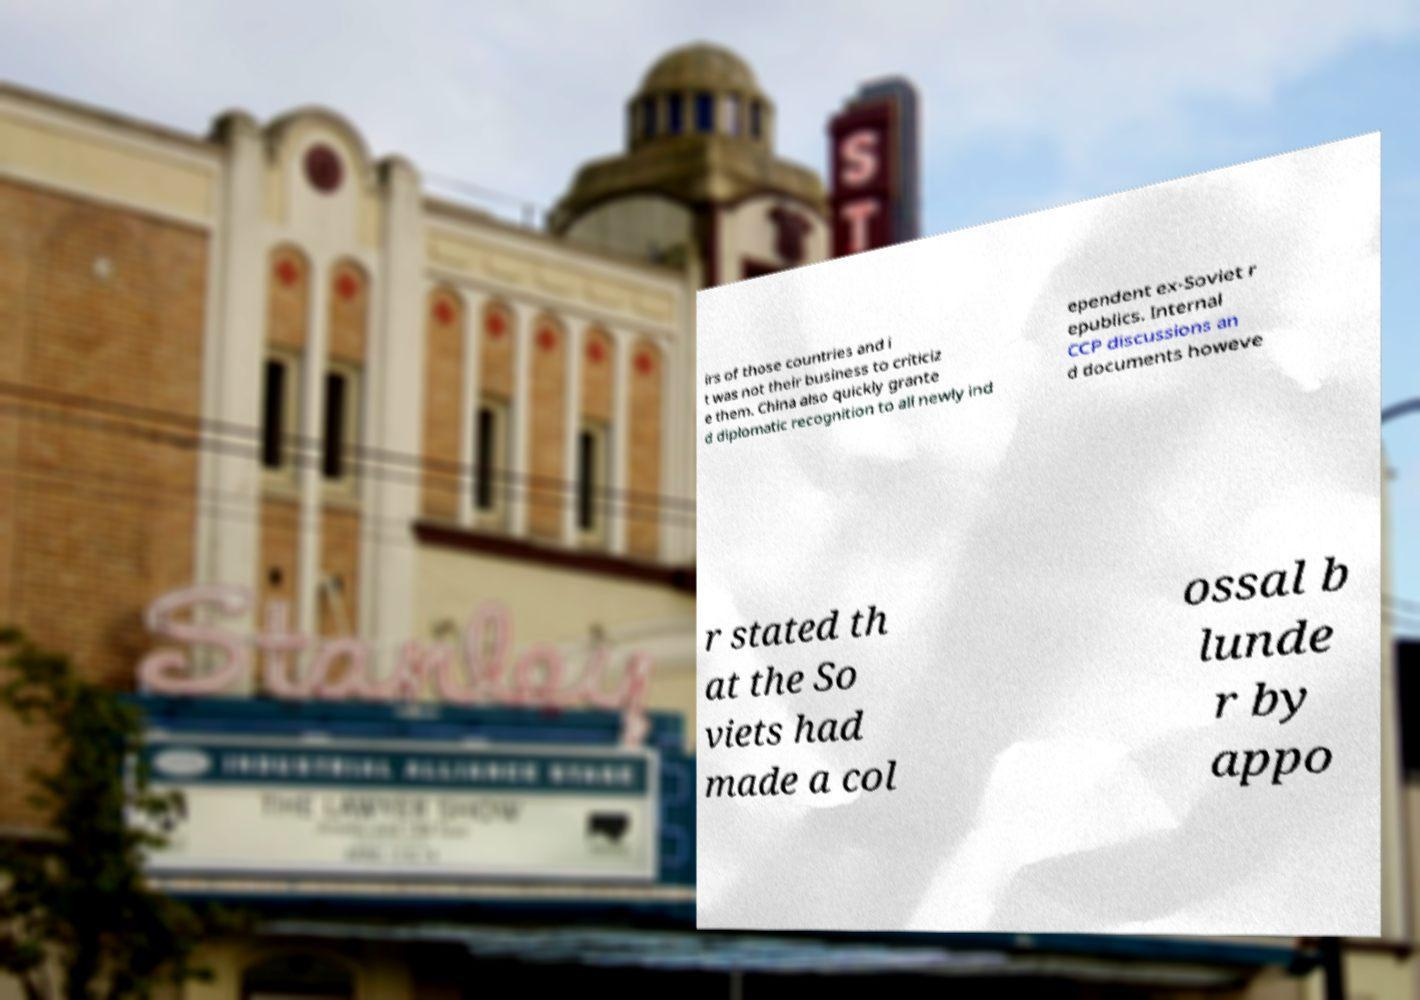There's text embedded in this image that I need extracted. Can you transcribe it verbatim? irs of those countries and i t was not their business to criticiz e them. China also quickly grante d diplomatic recognition to all newly ind ependent ex-Soviet r epublics. Internal CCP discussions an d documents howeve r stated th at the So viets had made a col ossal b lunde r by appo 